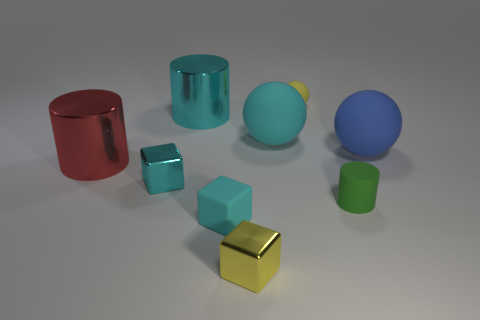There is a small cyan metallic thing; what shape is it?
Keep it short and to the point. Cube. What is the material of the blue ball that is the same size as the red shiny cylinder?
Offer a terse response. Rubber. Is the material of the large sphere that is to the right of the large cyan rubber ball the same as the large cyan ball?
Your answer should be very brief. Yes. There is a yellow rubber thing that is the same size as the cyan metal cube; what is its shape?
Your answer should be compact. Sphere. How many objects are the same color as the small ball?
Provide a short and direct response. 1. Is the number of small yellow balls in front of the red thing less than the number of big rubber balls behind the big blue rubber thing?
Your response must be concise. Yes. Are there any rubber spheres to the left of the blue object?
Provide a short and direct response. Yes. Is there a metallic thing to the right of the cyan metallic object in front of the large sphere in front of the cyan ball?
Ensure brevity in your answer.  Yes. Do the large cyan thing in front of the big cyan cylinder and the yellow matte object have the same shape?
Keep it short and to the point. Yes. The small ball that is made of the same material as the tiny green cylinder is what color?
Give a very brief answer. Yellow. 